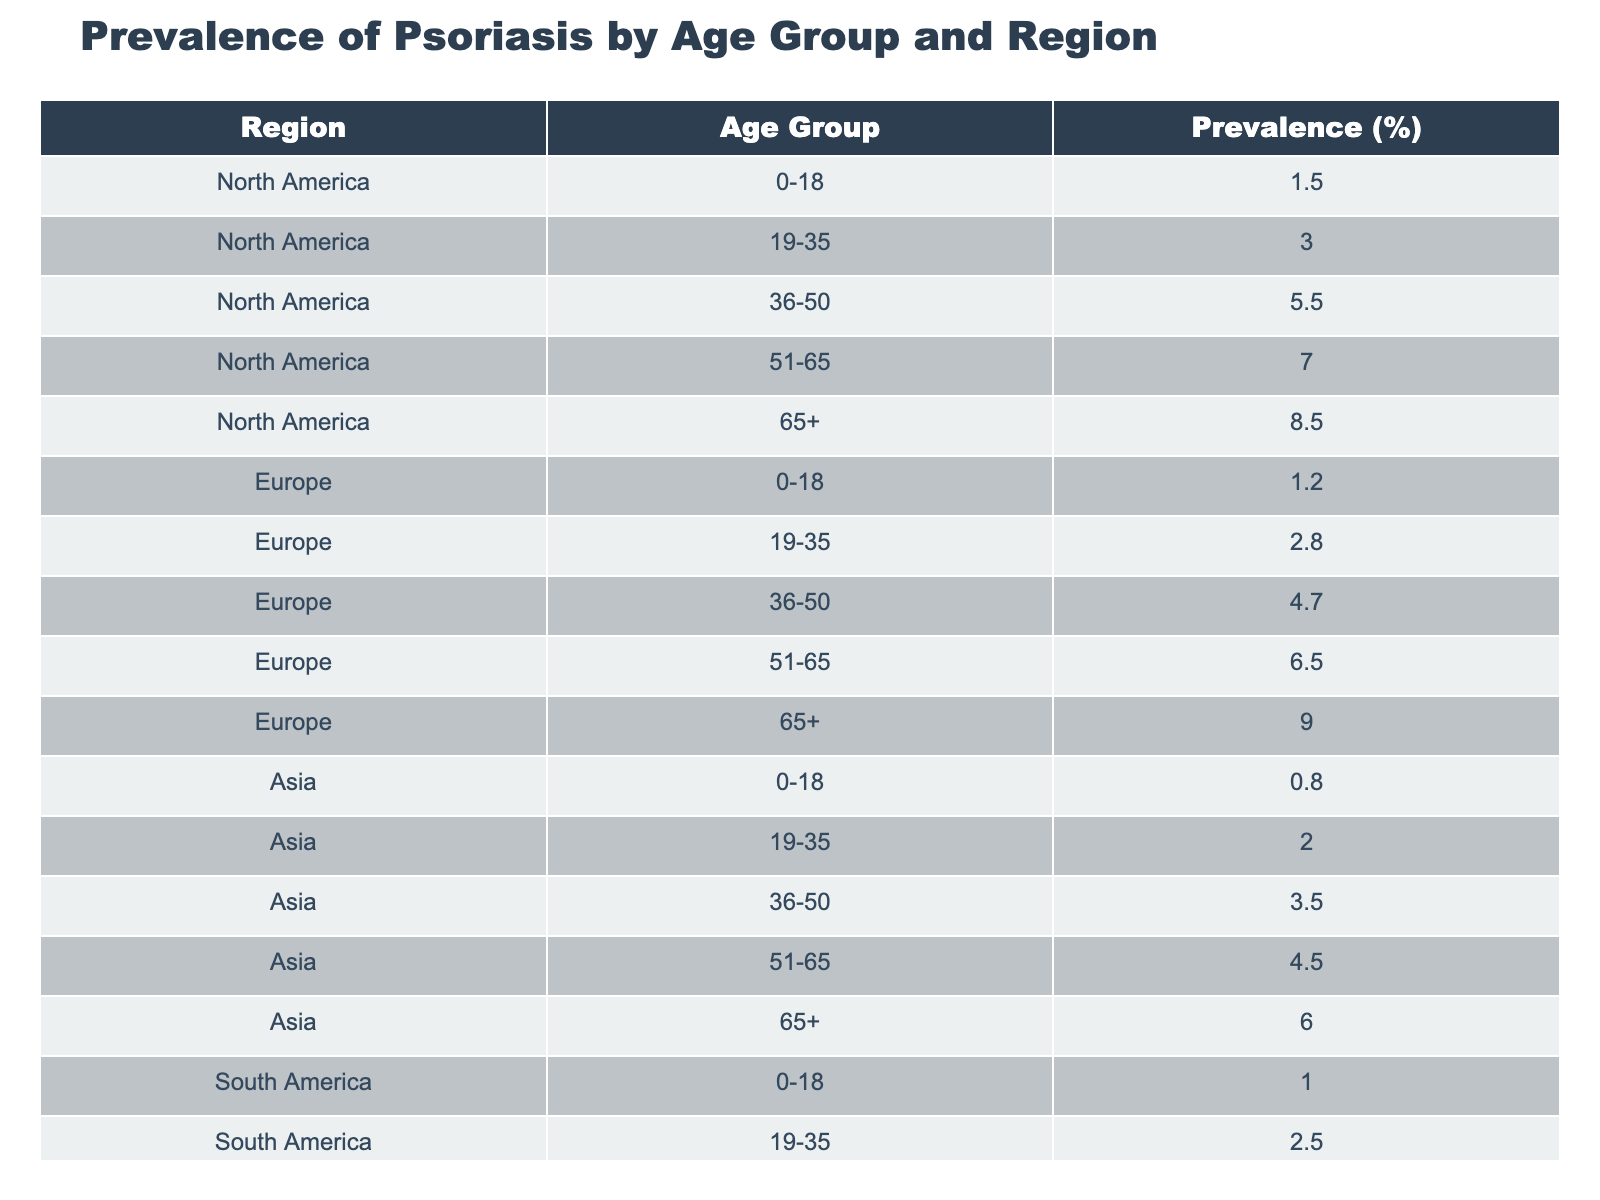What is the prevalence of psoriasis in the age group 51-65 in Europe? From the table, we can see that for the region of Europe, within the age group 51-65, the prevalence is listed directly as 6.5%.
Answer: 6.5% Which age group has the highest prevalence of psoriasis in North America? Reviewing the North America section, the age group with the highest prevalence is 65+, which has a value of 8.5%.
Answer: 65+ What is the average prevalence of psoriasis across all age groups in Asia? To find the average for Asia, we sum the prevalence values (0.8 + 2.0 + 3.5 + 4.5 + 6.0) = 16.8. There are 5 age groups, so we divide 16.8 by 5, which equals 3.36.
Answer: 3.36 Is the prevalence of psoriasis higher in South America or Asia for the age group 36-50? In South America, the prevalence for 36-50 is 4.0%, whereas in Asia it is 3.5%. Since 4.0% is greater than 3.5%, the prevalence is higher in South America.
Answer: Yes What is the difference in prevalence between the age group 19-35 and the age group 51-65 in Oceania? In Oceania, the prevalence for the age group 19-35 is 2.3%, while for the age group 51-65 it is 5.7%. The difference is calculated as 5.7 - 2.3 = 3.4%.
Answer: 3.4% 